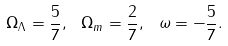<formula> <loc_0><loc_0><loc_500><loc_500>\Omega _ { \Lambda } = \frac { 5 } { 7 } , \ \Omega _ { m } = \frac { 2 } { 7 } , \ \omega = - \frac { 5 } { 7 } .</formula> 